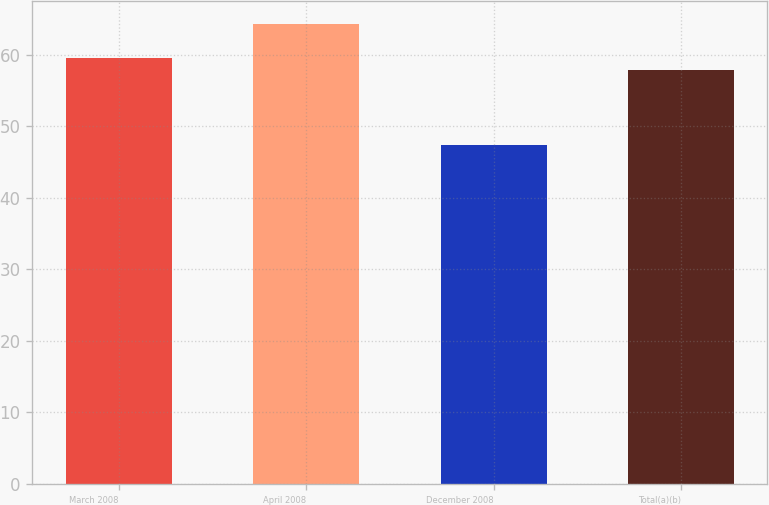Convert chart. <chart><loc_0><loc_0><loc_500><loc_500><bar_chart><fcel>March 2008<fcel>April 2008<fcel>December 2008<fcel>Total(a)(b)<nl><fcel>59.61<fcel>64.27<fcel>47.41<fcel>57.82<nl></chart> 